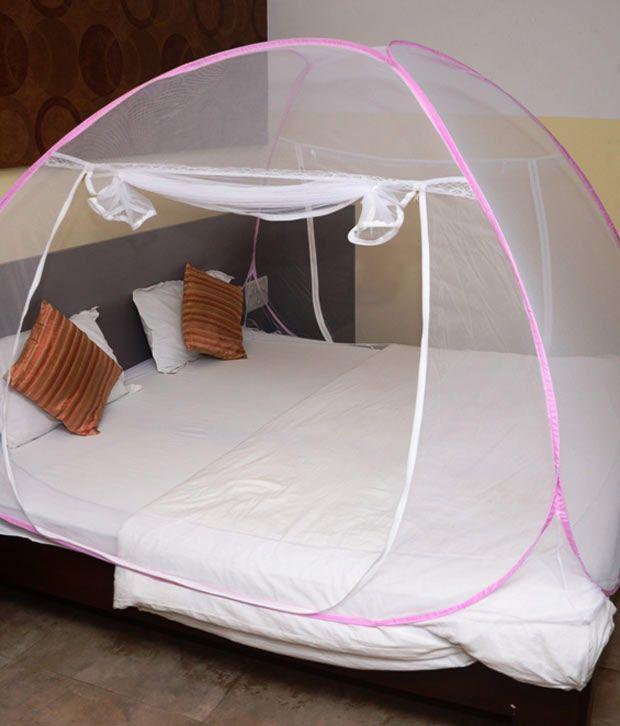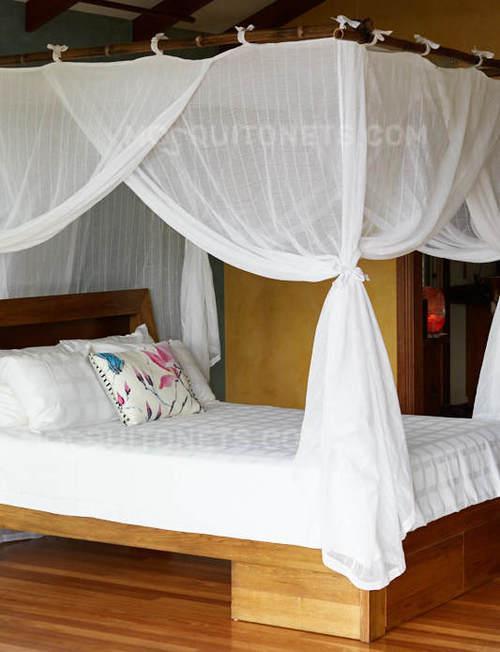The first image is the image on the left, the second image is the image on the right. For the images displayed, is the sentence "In one image, gauzy bed curtains are draped from a square frame, and knotted halfway down at each corner." factually correct? Answer yes or no. Yes. 